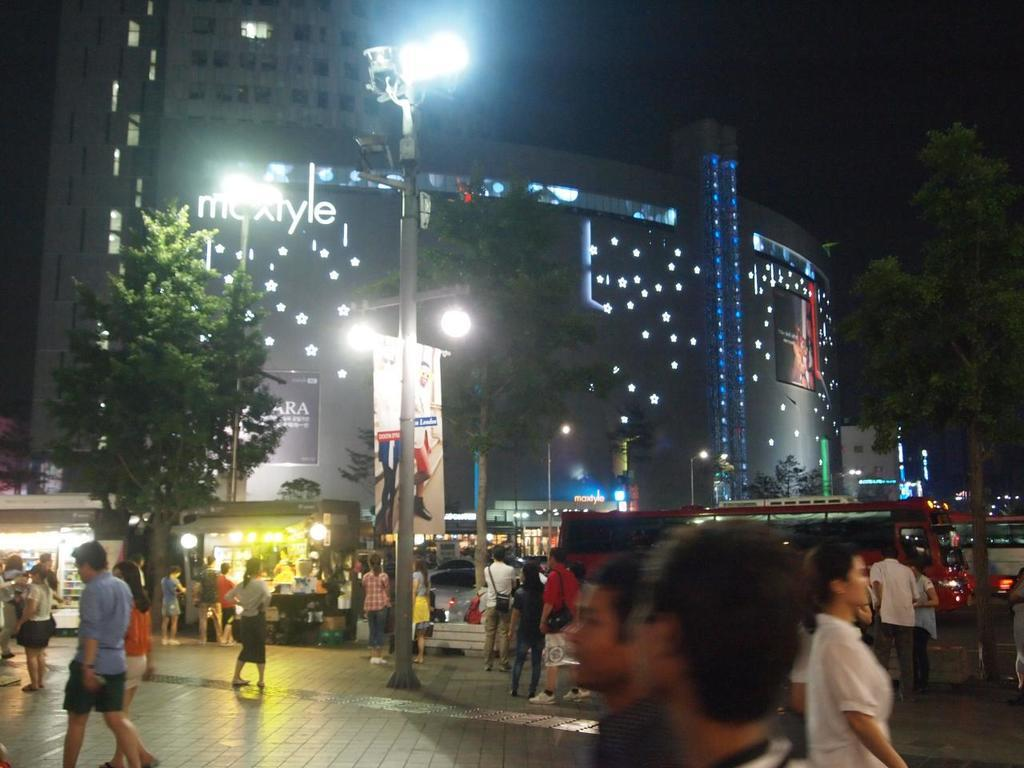What structures can be seen in the image? There are poles, lights, banners, and buildings in the image. What type of vegetation is present in the image? There are trees in the image. What else can be seen in the image besides structures and vegetation? There are vehicles and people in the image. What is visible in the background of the image? There are buildings in the background of the image. Can you see any mountains in the image? There are no mountains present in the image. How many bikes are being ridden by the people in the image? There are no bikes visible in the image; only vehicles and people are present. 